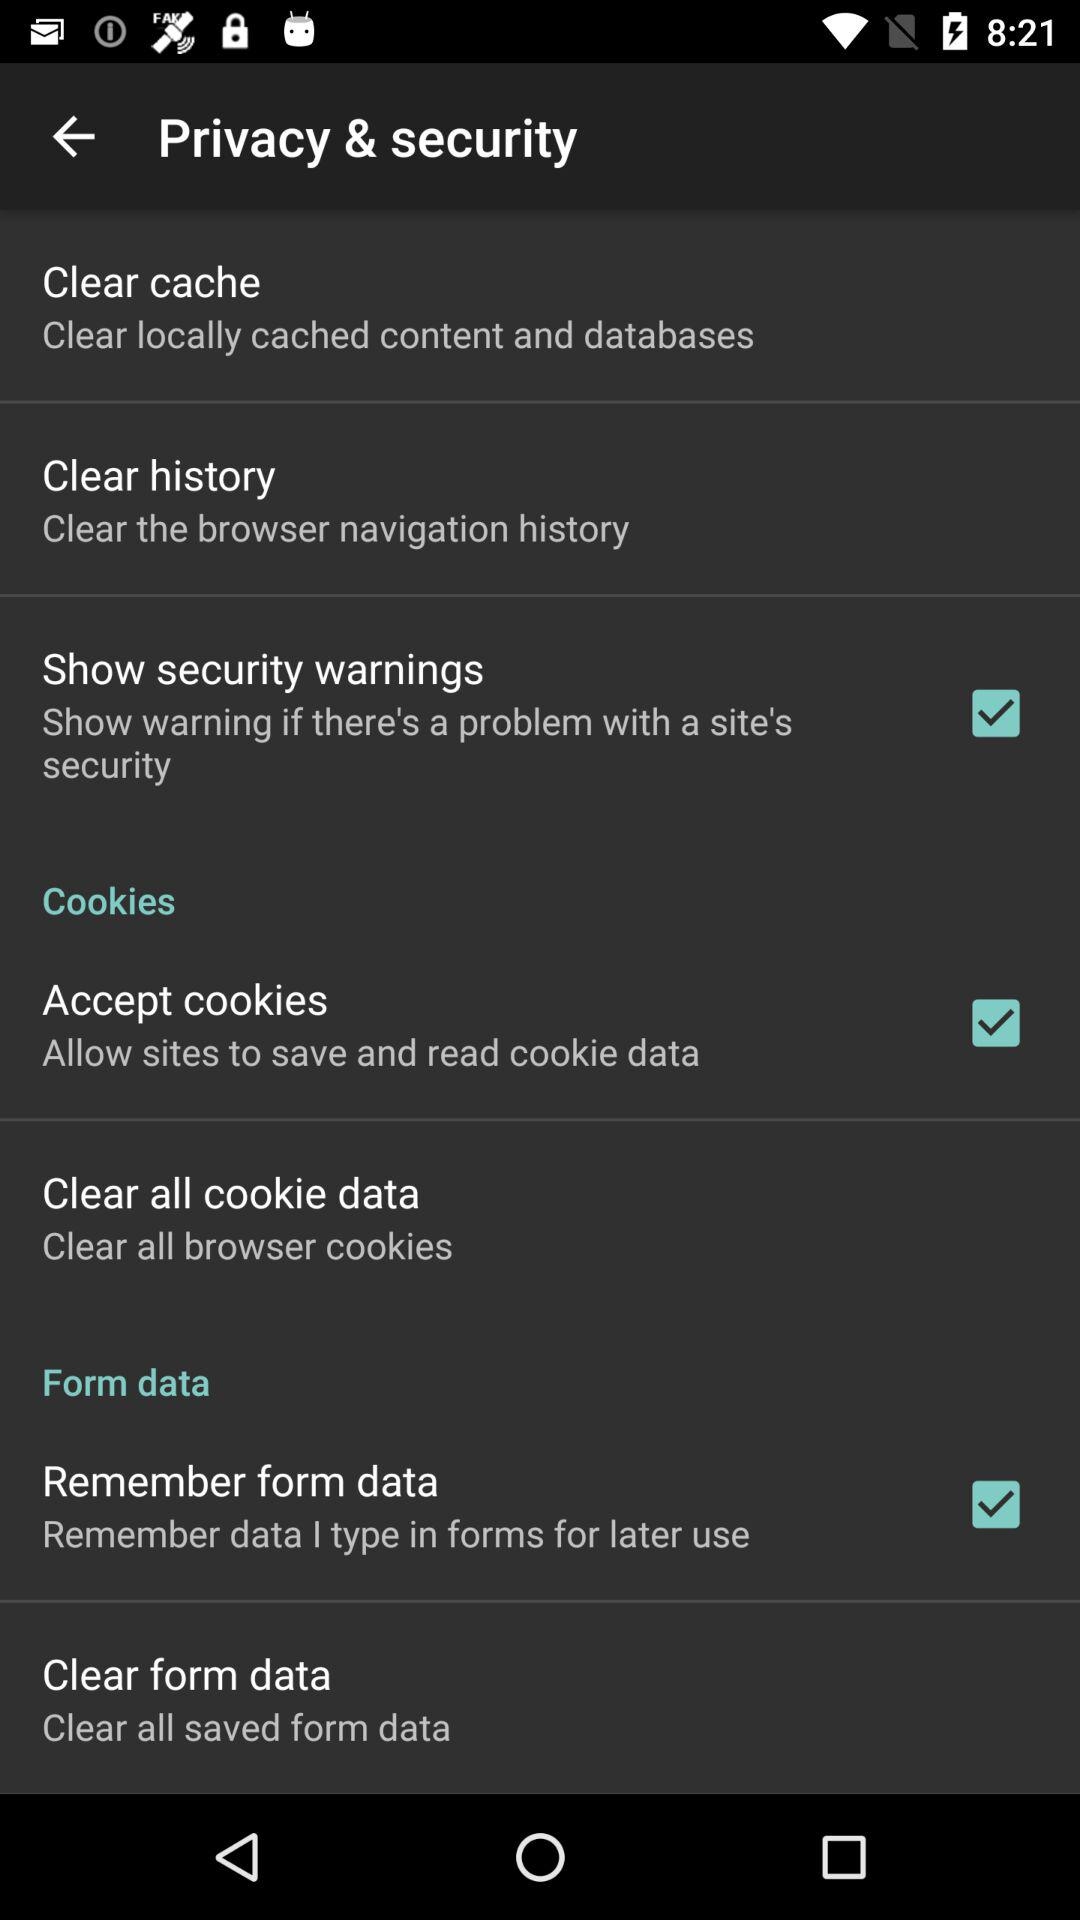What is the status of the "Show security warnings"? The status of the "Show security warnings" is "on". 